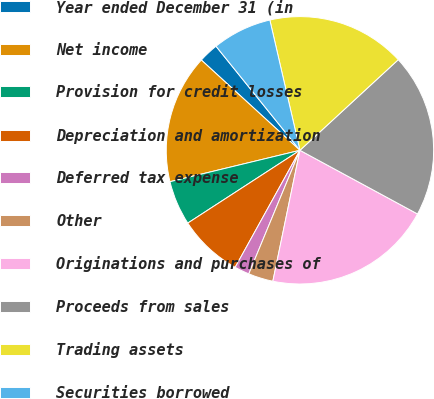Convert chart to OTSL. <chart><loc_0><loc_0><loc_500><loc_500><pie_chart><fcel>Year ended December 31 (in<fcel>Net income<fcel>Provision for credit losses<fcel>Depreciation and amortization<fcel>Deferred tax expense<fcel>Other<fcel>Originations and purchases of<fcel>Proceeds from sales<fcel>Trading assets<fcel>Securities borrowed<nl><fcel>2.4%<fcel>15.57%<fcel>5.39%<fcel>7.79%<fcel>1.8%<fcel>3.0%<fcel>20.35%<fcel>19.75%<fcel>16.76%<fcel>7.19%<nl></chart> 